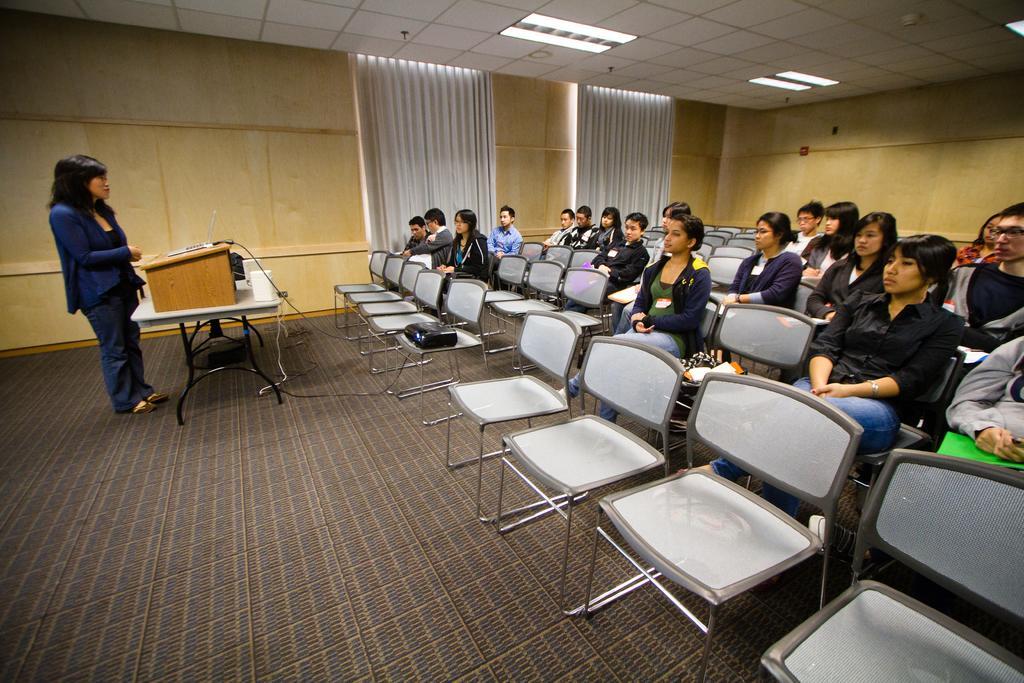Describe this image in one or two sentences. These group of people are sitting on chairs. Lights are attached to ceiling. This woman is standing and wore blue jacket. On this table there is a box and cups. This is curtains. On this chair there is a projector. 